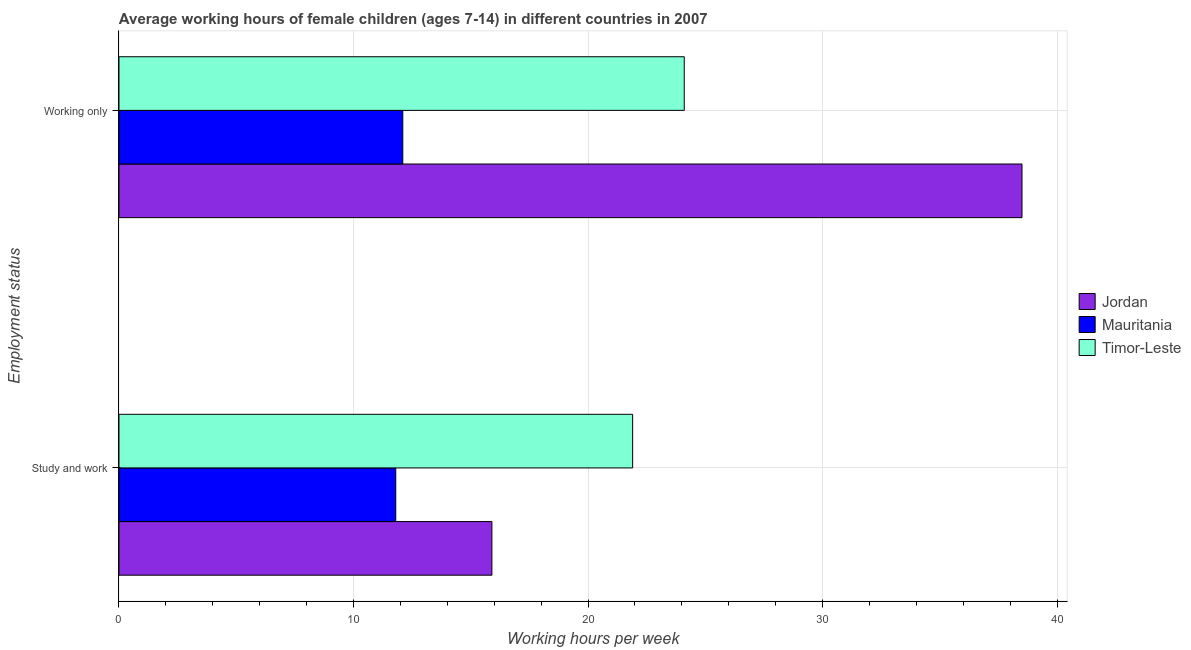How many groups of bars are there?
Make the answer very short. 2. How many bars are there on the 1st tick from the bottom?
Offer a very short reply. 3. What is the label of the 1st group of bars from the top?
Your response must be concise. Working only. What is the average working hour of children involved in study and work in Mauritania?
Keep it short and to the point. 11.8. Across all countries, what is the maximum average working hour of children involved in only work?
Your answer should be compact. 38.5. In which country was the average working hour of children involved in study and work maximum?
Keep it short and to the point. Timor-Leste. In which country was the average working hour of children involved in only work minimum?
Keep it short and to the point. Mauritania. What is the total average working hour of children involved in only work in the graph?
Give a very brief answer. 74.7. What is the difference between the average working hour of children involved in study and work in Jordan and that in Timor-Leste?
Provide a short and direct response. -6. What is the difference between the average working hour of children involved in study and work in Jordan and the average working hour of children involved in only work in Timor-Leste?
Your answer should be compact. -8.2. What is the average average working hour of children involved in study and work per country?
Offer a very short reply. 16.53. What is the difference between the average working hour of children involved in study and work and average working hour of children involved in only work in Timor-Leste?
Give a very brief answer. -2.2. What is the ratio of the average working hour of children involved in study and work in Mauritania to that in Timor-Leste?
Make the answer very short. 0.54. Is the average working hour of children involved in study and work in Jordan less than that in Mauritania?
Ensure brevity in your answer.  No. In how many countries, is the average working hour of children involved in only work greater than the average average working hour of children involved in only work taken over all countries?
Offer a terse response. 1. What does the 2nd bar from the top in Study and work represents?
Ensure brevity in your answer.  Mauritania. What does the 3rd bar from the bottom in Study and work represents?
Your response must be concise. Timor-Leste. How many bars are there?
Make the answer very short. 6. Are all the bars in the graph horizontal?
Ensure brevity in your answer.  Yes. How many countries are there in the graph?
Ensure brevity in your answer.  3. What is the difference between two consecutive major ticks on the X-axis?
Provide a succinct answer. 10. Are the values on the major ticks of X-axis written in scientific E-notation?
Your response must be concise. No. Does the graph contain any zero values?
Your response must be concise. No. Does the graph contain grids?
Your response must be concise. Yes. What is the title of the graph?
Your answer should be very brief. Average working hours of female children (ages 7-14) in different countries in 2007. What is the label or title of the X-axis?
Ensure brevity in your answer.  Working hours per week. What is the label or title of the Y-axis?
Ensure brevity in your answer.  Employment status. What is the Working hours per week of Jordan in Study and work?
Offer a terse response. 15.9. What is the Working hours per week of Timor-Leste in Study and work?
Keep it short and to the point. 21.9. What is the Working hours per week of Jordan in Working only?
Provide a succinct answer. 38.5. What is the Working hours per week in Mauritania in Working only?
Provide a short and direct response. 12.1. What is the Working hours per week in Timor-Leste in Working only?
Your response must be concise. 24.1. Across all Employment status, what is the maximum Working hours per week of Jordan?
Give a very brief answer. 38.5. Across all Employment status, what is the maximum Working hours per week of Mauritania?
Offer a very short reply. 12.1. Across all Employment status, what is the maximum Working hours per week in Timor-Leste?
Your answer should be compact. 24.1. Across all Employment status, what is the minimum Working hours per week of Jordan?
Provide a short and direct response. 15.9. Across all Employment status, what is the minimum Working hours per week in Mauritania?
Give a very brief answer. 11.8. Across all Employment status, what is the minimum Working hours per week in Timor-Leste?
Ensure brevity in your answer.  21.9. What is the total Working hours per week of Jordan in the graph?
Provide a succinct answer. 54.4. What is the total Working hours per week of Mauritania in the graph?
Provide a short and direct response. 23.9. What is the total Working hours per week of Timor-Leste in the graph?
Offer a very short reply. 46. What is the difference between the Working hours per week of Jordan in Study and work and that in Working only?
Offer a very short reply. -22.6. What is the difference between the Working hours per week of Mauritania in Study and work and that in Working only?
Keep it short and to the point. -0.3. What is the difference between the Working hours per week in Timor-Leste in Study and work and that in Working only?
Your answer should be very brief. -2.2. What is the difference between the Working hours per week in Mauritania in Study and work and the Working hours per week in Timor-Leste in Working only?
Give a very brief answer. -12.3. What is the average Working hours per week of Jordan per Employment status?
Give a very brief answer. 27.2. What is the average Working hours per week of Mauritania per Employment status?
Give a very brief answer. 11.95. What is the difference between the Working hours per week in Jordan and Working hours per week in Timor-Leste in Study and work?
Give a very brief answer. -6. What is the difference between the Working hours per week of Jordan and Working hours per week of Mauritania in Working only?
Offer a very short reply. 26.4. What is the difference between the Working hours per week of Jordan and Working hours per week of Timor-Leste in Working only?
Provide a short and direct response. 14.4. What is the ratio of the Working hours per week in Jordan in Study and work to that in Working only?
Keep it short and to the point. 0.41. What is the ratio of the Working hours per week in Mauritania in Study and work to that in Working only?
Keep it short and to the point. 0.98. What is the ratio of the Working hours per week in Timor-Leste in Study and work to that in Working only?
Offer a terse response. 0.91. What is the difference between the highest and the second highest Working hours per week in Jordan?
Your response must be concise. 22.6. What is the difference between the highest and the lowest Working hours per week of Jordan?
Ensure brevity in your answer.  22.6. What is the difference between the highest and the lowest Working hours per week in Mauritania?
Your answer should be very brief. 0.3. 